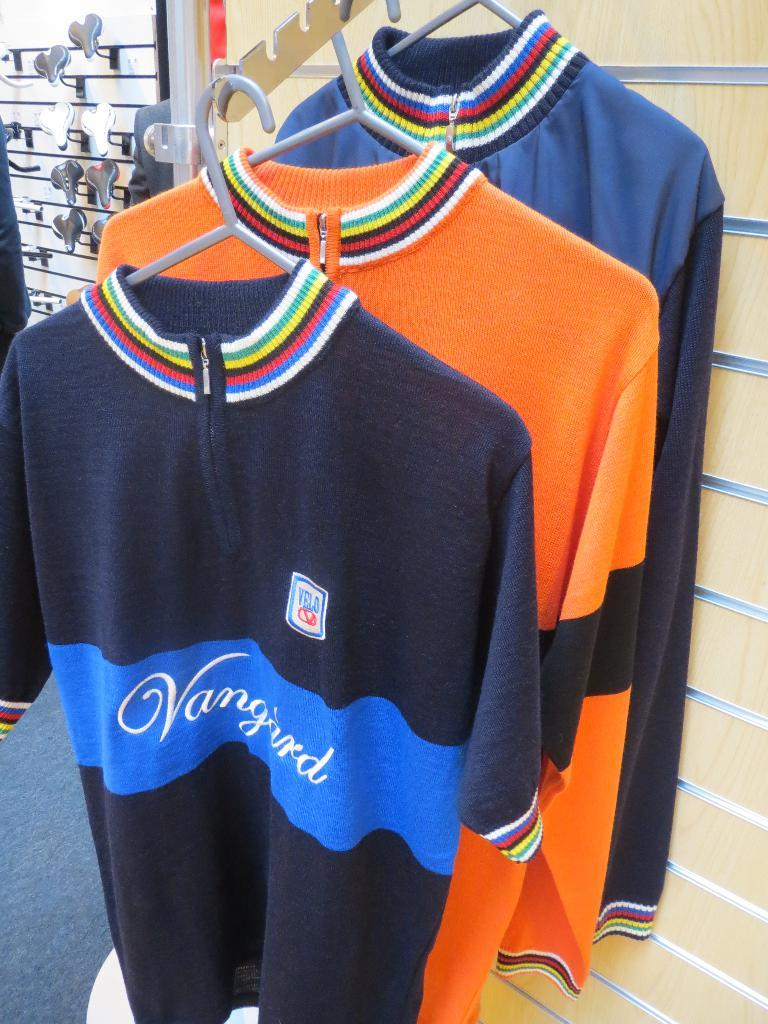<image>
Offer a succinct explanation of the picture presented. Three sweaters are on display, including one in front which reads "Vanguard." 